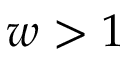Convert formula to latex. <formula><loc_0><loc_0><loc_500><loc_500>w > 1</formula> 